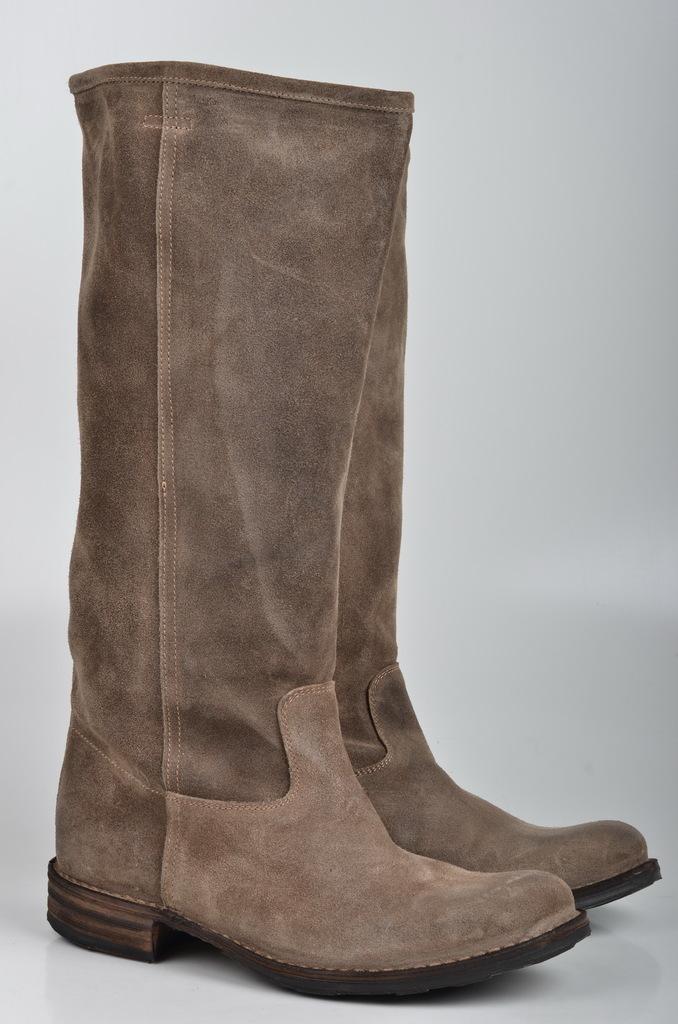Could you give a brief overview of what you see in this image? In this image there is a pair of boots. 